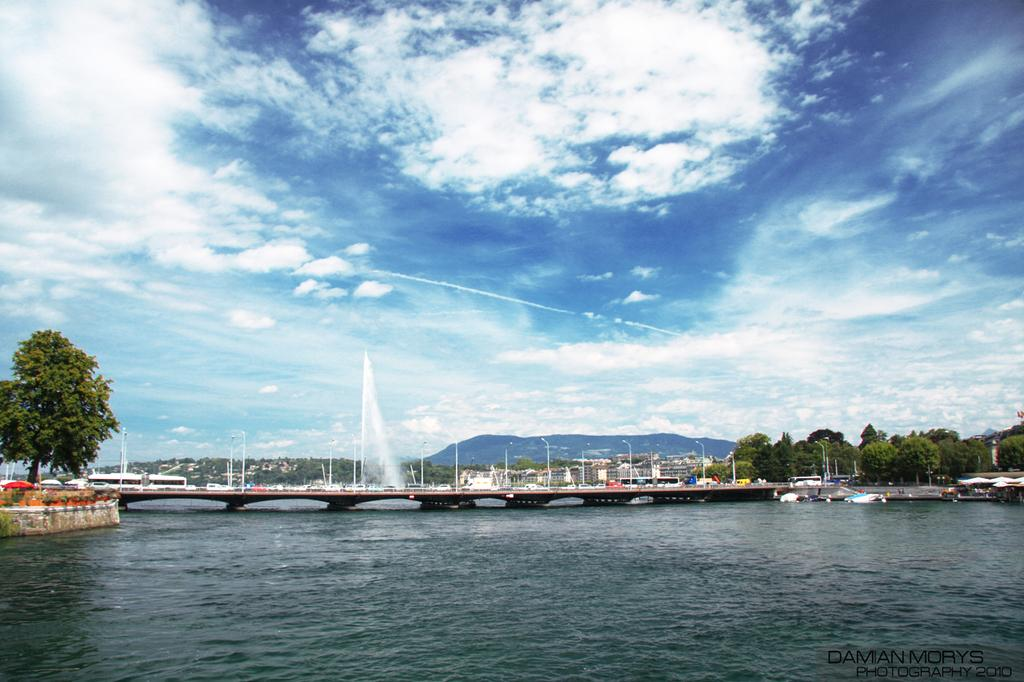What is at the bottom of the image? There is water at the bottom of the image. What structure can be seen in the middle of the image? There is a bridge in the middle of the image. What type of vegetation is on the right side of the image? There are green trees on the right side of the image. What color is the sky in the image? The sky is blue at the top of the image. What advice is given by the fog in the image? There is no fog present in the image, so no advice can be given. How does the death of the trees affect the image? There are no dead trees in the image, so their death does not affect the image. 